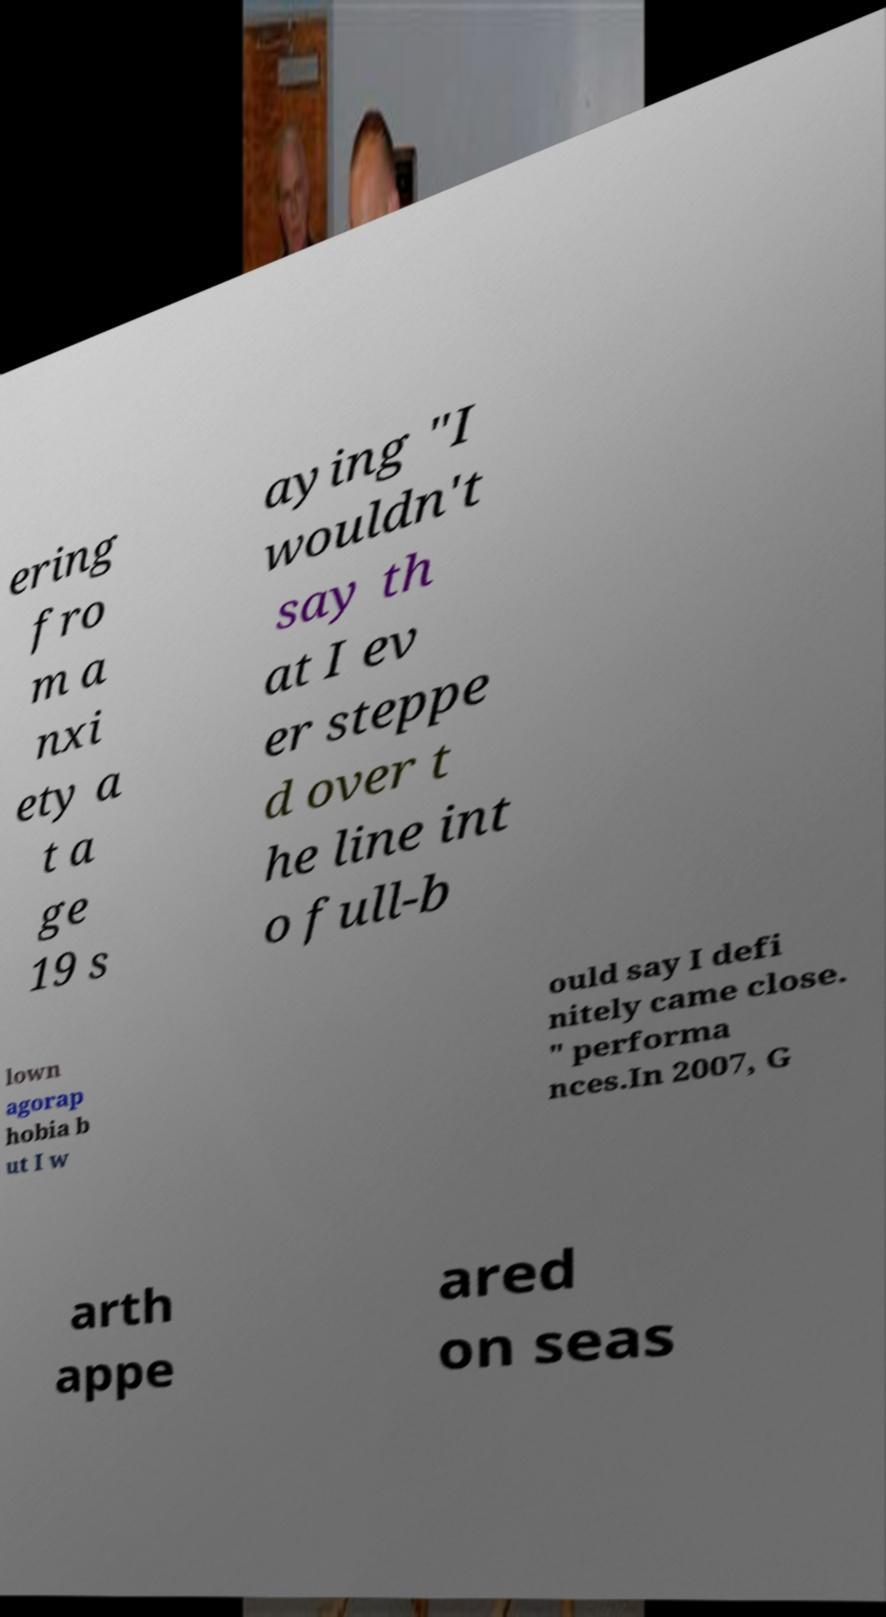I need the written content from this picture converted into text. Can you do that? ering fro m a nxi ety a t a ge 19 s aying "I wouldn't say th at I ev er steppe d over t he line int o full-b lown agorap hobia b ut I w ould say I defi nitely came close. " performa nces.In 2007, G arth appe ared on seas 